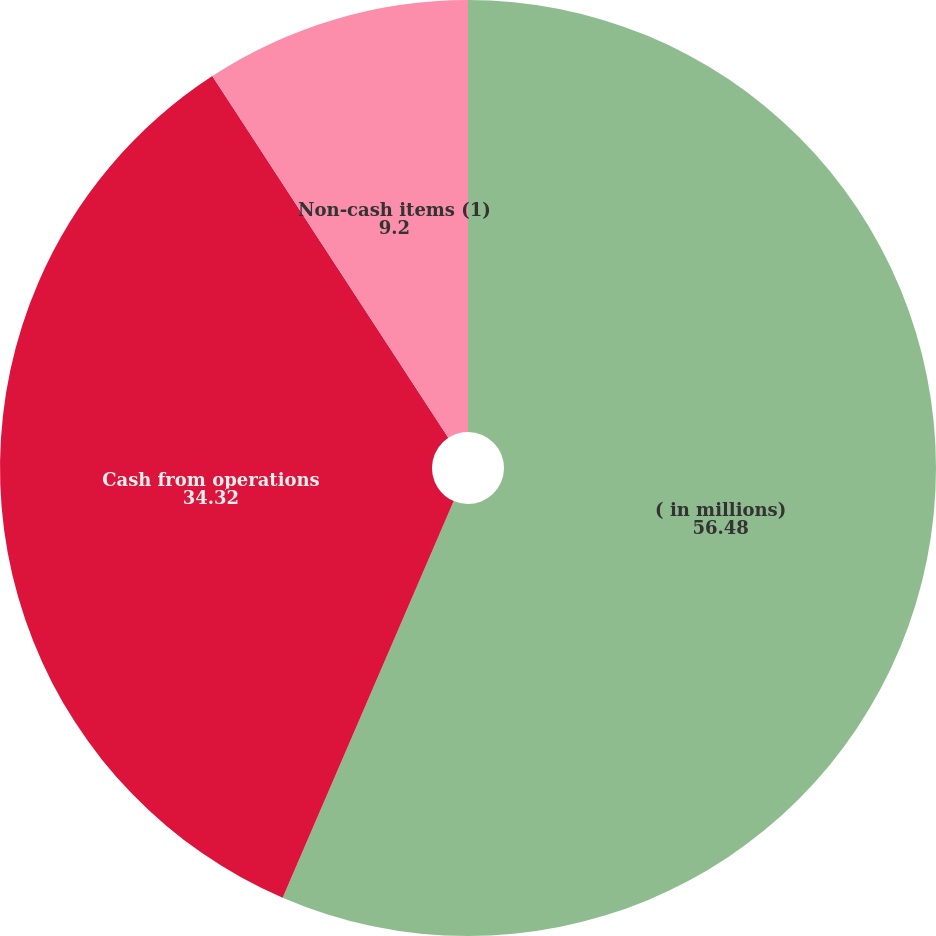Convert chart to OTSL. <chart><loc_0><loc_0><loc_500><loc_500><pie_chart><fcel>( in millions)<fcel>Cash from operations<fcel>Non-cash items (1)<nl><fcel>56.48%<fcel>34.32%<fcel>9.2%<nl></chart> 